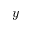<formula> <loc_0><loc_0><loc_500><loc_500>y</formula> 